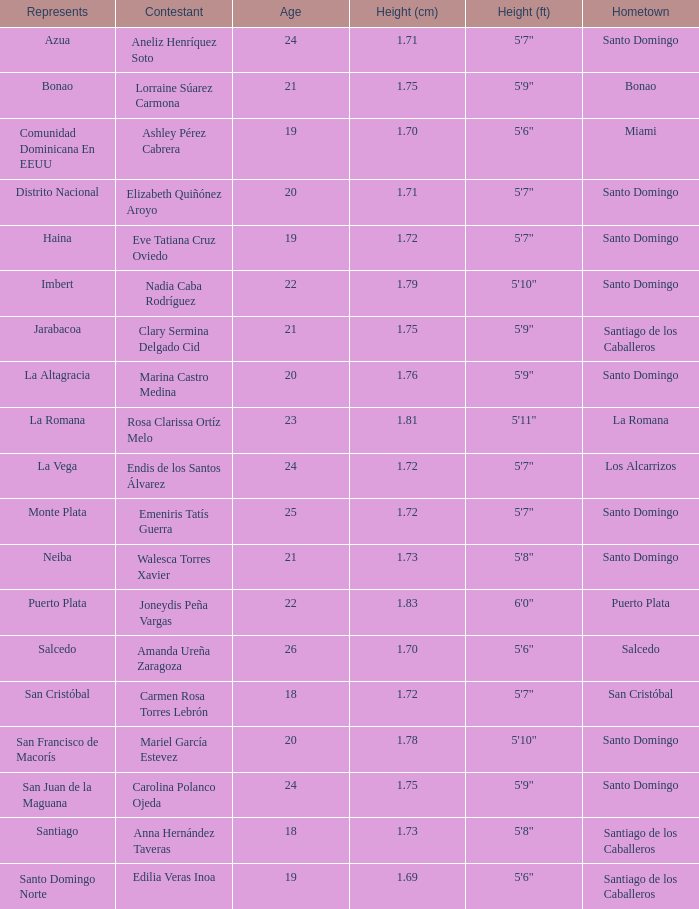Specify the spokespersons for los alcarrizos. La Vega. 